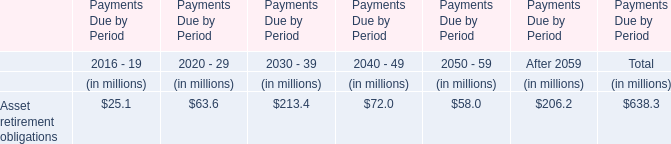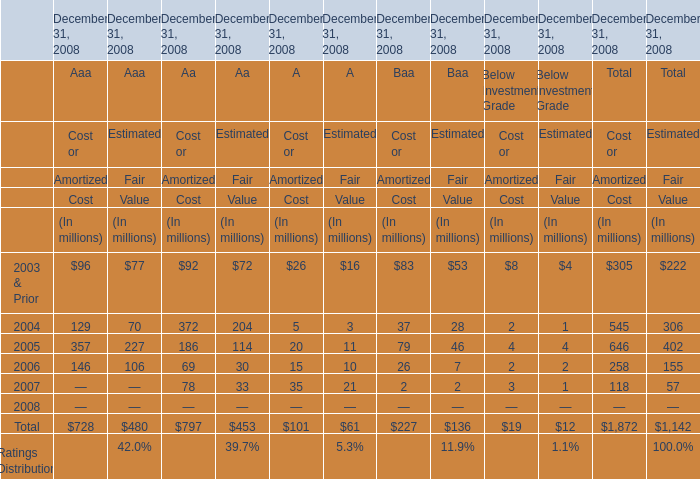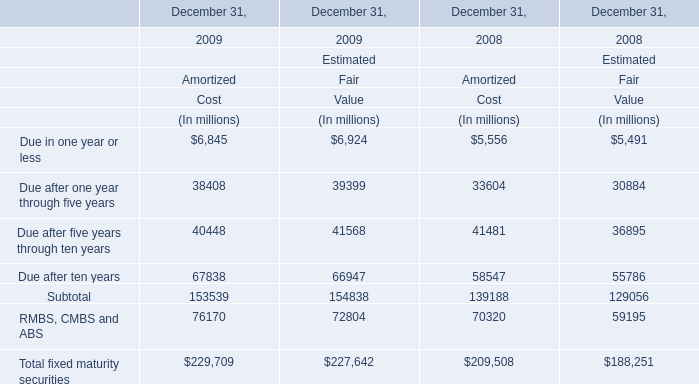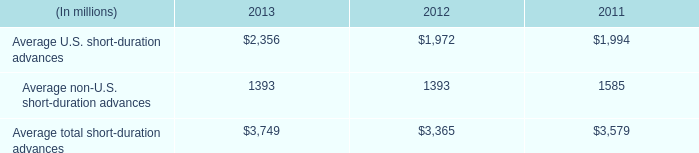What is the row number of the section in which the amount of Amortized Cost in 2009 has the highest value? 
Answer: 12. 